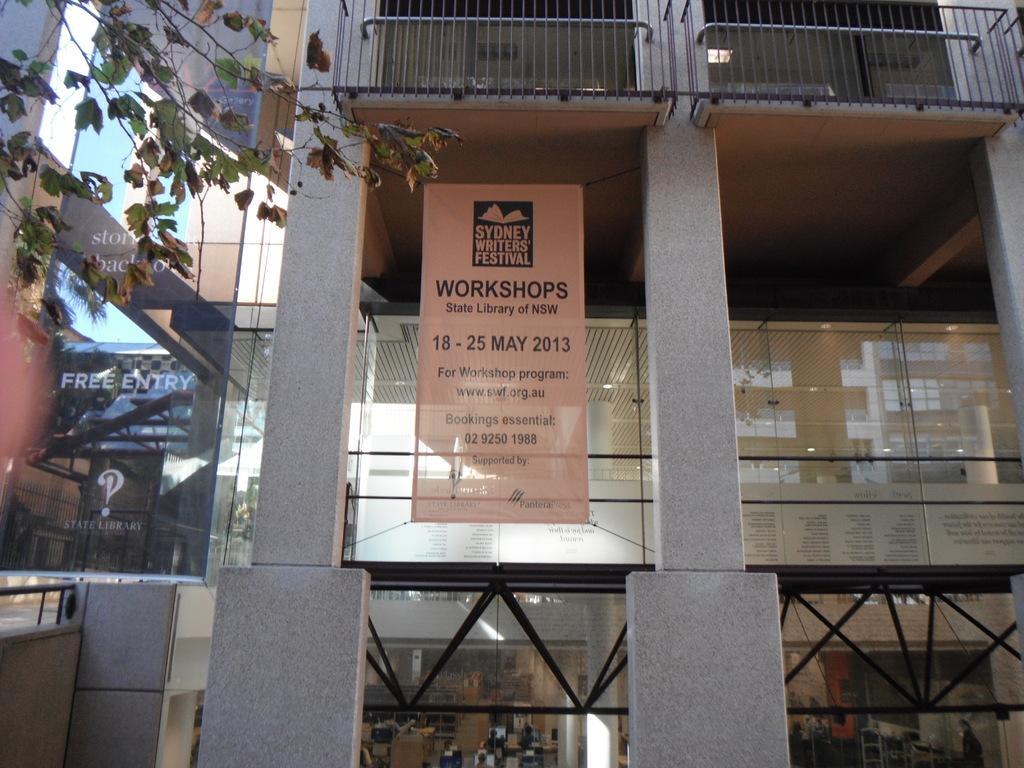Describe this image in one or two sentences. In this image we can see a building and there is a poster with some text and we can see some boards with the text and there are some other objects and on the left side of the image we can see a tree. 